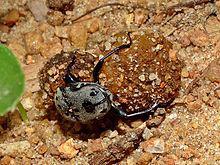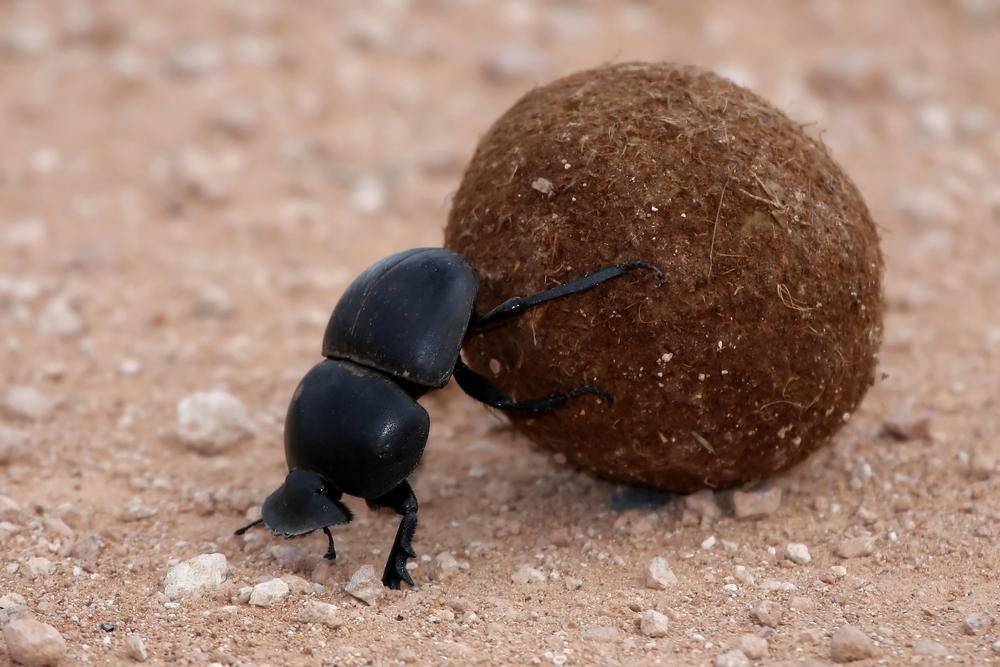The first image is the image on the left, the second image is the image on the right. Analyze the images presented: Is the assertion "The insect in the image on the right is standing on top of the ball." valid? Answer yes or no. No. 